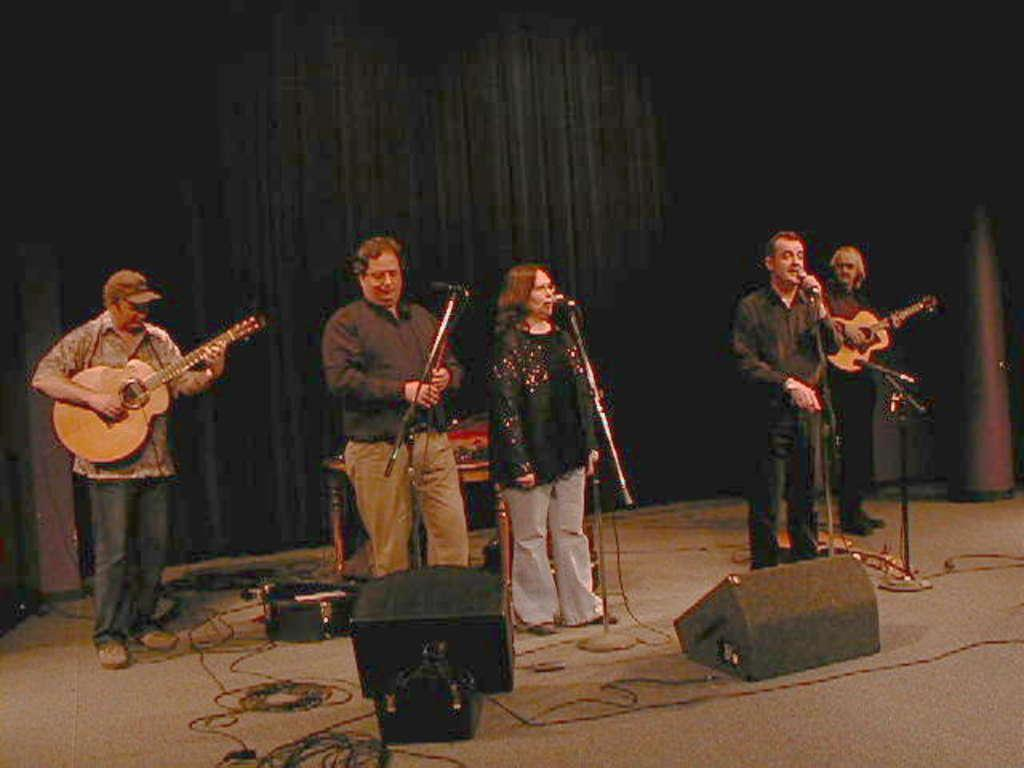What are the persons in the image doing? The persons in the image are standing in front of a microphone and singing. What musical instrument can be seen in the image? At least one person is playing a guitar in the image. What type of structure is present in the image? There is a platform in the image. What is used to transmit sound in the image? There are wires and speakers visible in the image. What can be seen in the background of the image? There is a black curtain in the background of the image. What type of cakes are being served on the bed in the image? There is no bed or cakes present in the image; it features persons singing with a guitar and other equipment. 